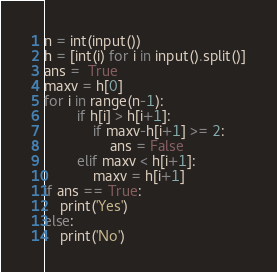<code> <loc_0><loc_0><loc_500><loc_500><_Python_>n = int(input())
h = [int(i) for i in input().split()]
ans =  True
maxv = h[0]
for i in range(n-1):
        if h[i] > h[i+1]:
            if maxv-h[i+1] >= 2:
                ans = False
        elif maxv < h[i+1]:
            maxv = h[i+1]
if ans == True:
    print('Yes')
else:
    print('No')</code> 